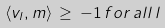<formula> <loc_0><loc_0><loc_500><loc_500>\langle { v } _ { l } , { m } \rangle \, \geq \, - 1 \, f o r \, a l l \, l</formula> 